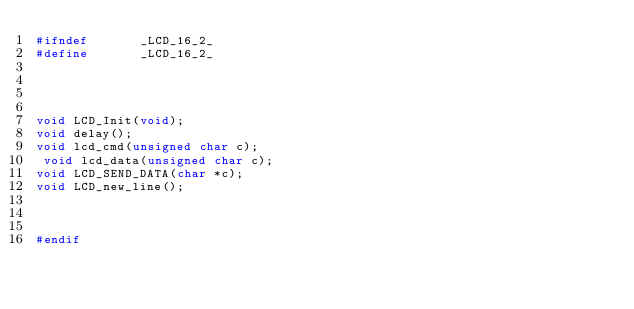<code> <loc_0><loc_0><loc_500><loc_500><_C_>#ifndef       _LCD_16_2_
#define       _LCD_16_2_




void LCD_Init(void);
void delay();
void lcd_cmd(unsigned char c);
 void lcd_data(unsigned char c);
void LCD_SEND_DATA(char *c);
void LCD_new_line();



#endif
</code> 